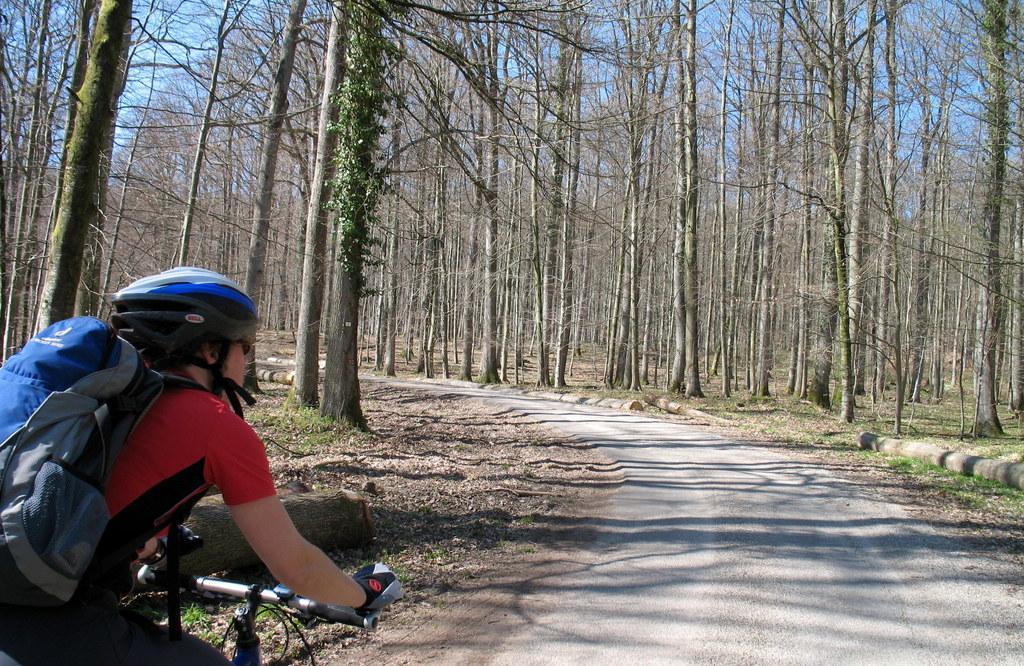Can you describe this image briefly? In this image I can see a person wearing helmet and riding bicycle on the road, side there are so many trees. 